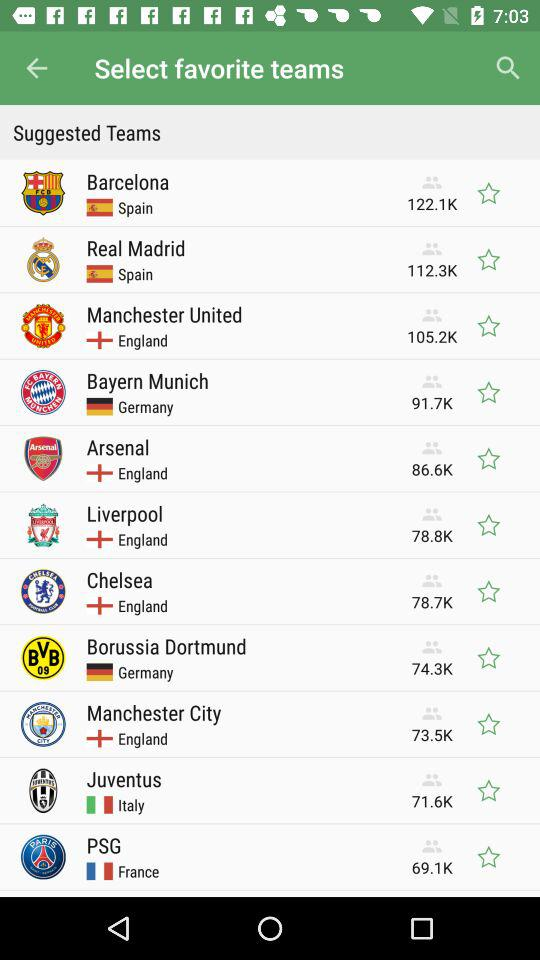What are the available teams on the list? The available teams are "Barcelona", "Real Madrid", "Manchester United", "Bayern Munich", "Arsenal", "Liverpool", "Chelsea", "Borussia Dortmund", "Manchester City", "Juventus" and "PSG". 